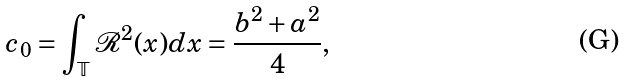Convert formula to latex. <formula><loc_0><loc_0><loc_500><loc_500>c _ { 0 } = \int _ { \mathbb { T } } \mathcal { R } ^ { 2 } ( x ) d x = \frac { b ^ { 2 } + a ^ { 2 } } { 4 } ,</formula> 